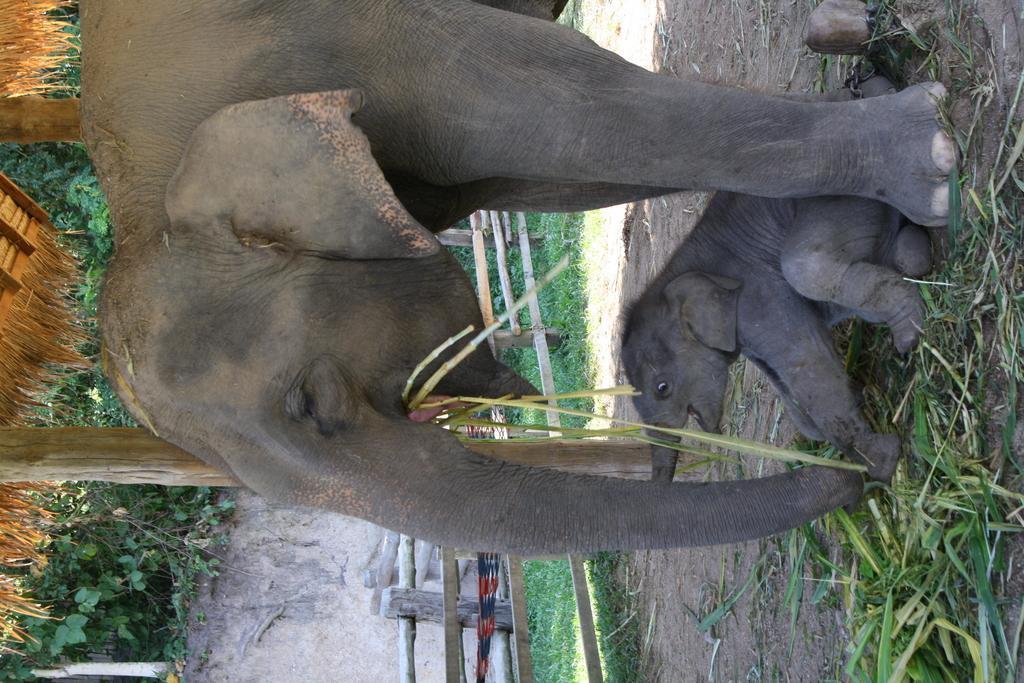Can you describe this image briefly? In this picture there is a huge elephant eating a grass and below a small baby elephant sitting on the ground. Behind there are some green plants. 